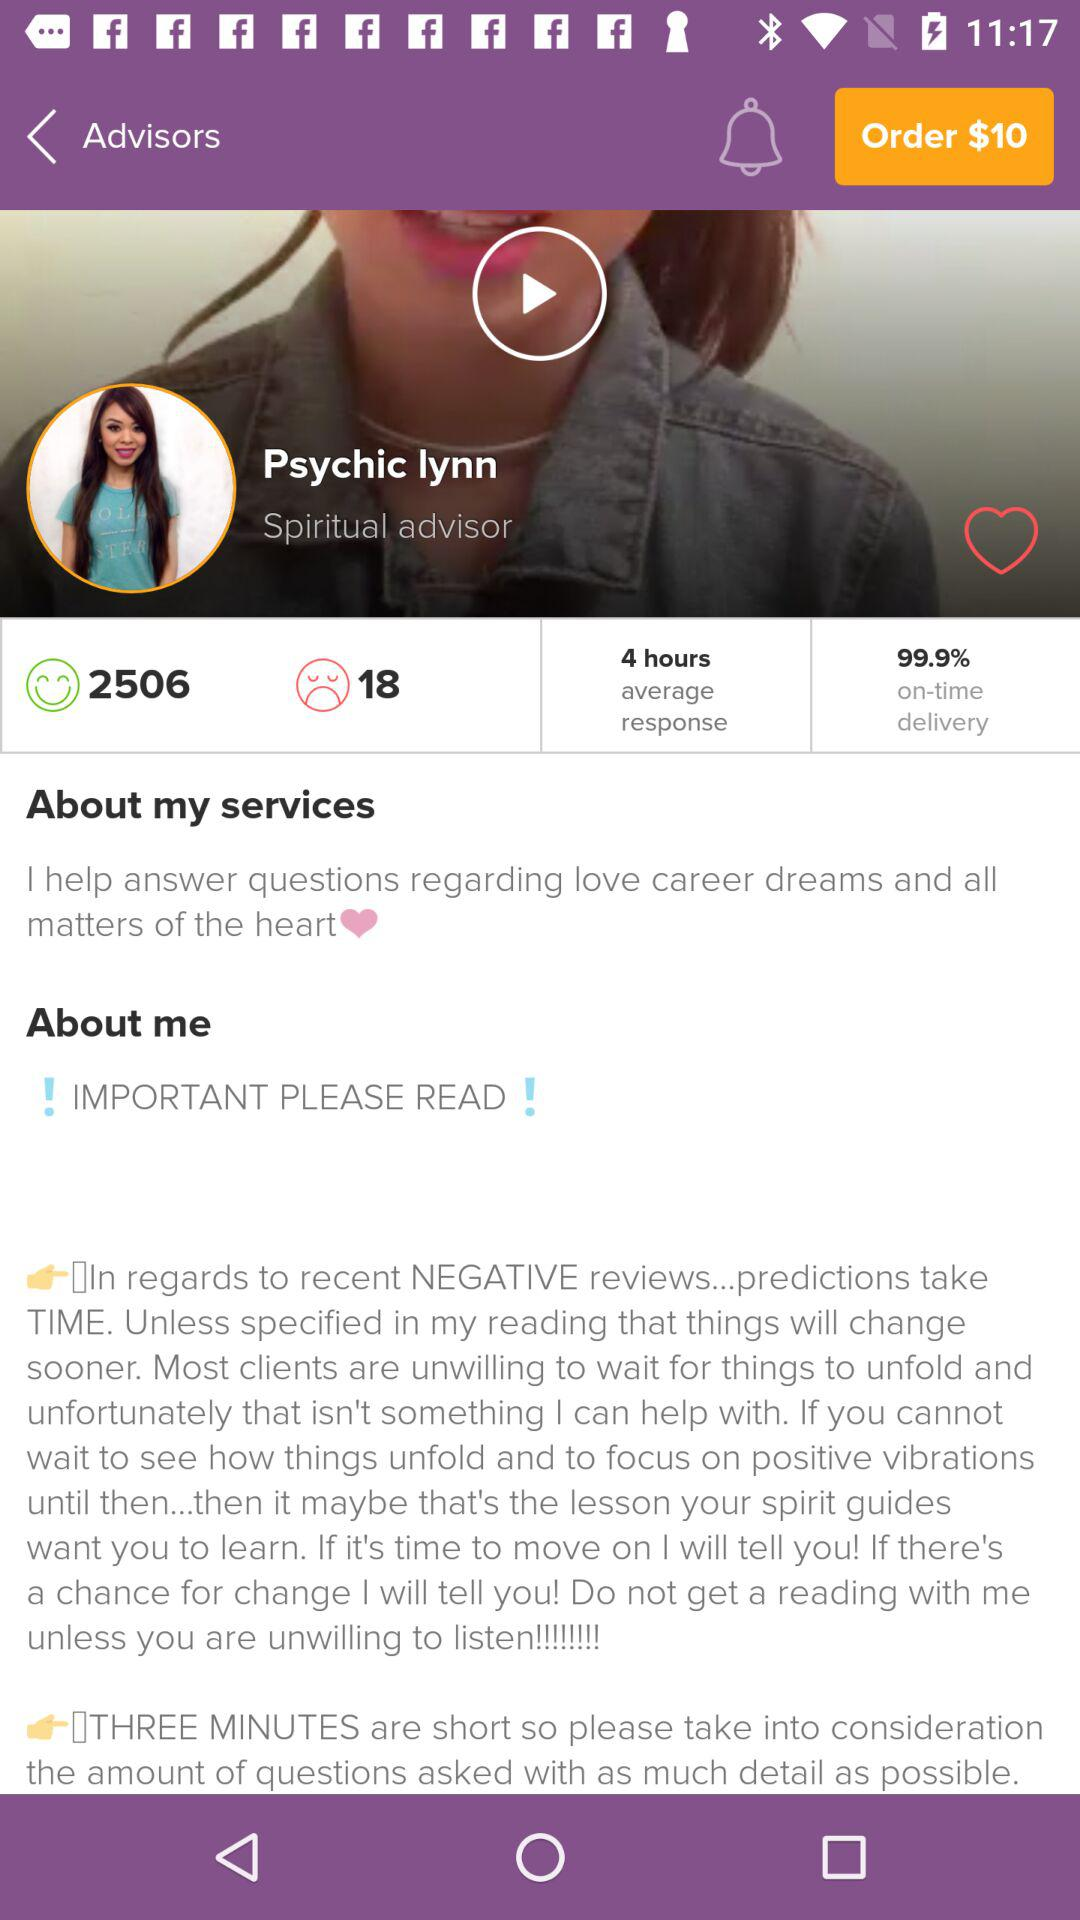What is the count of unhappy users? The count is 18. 